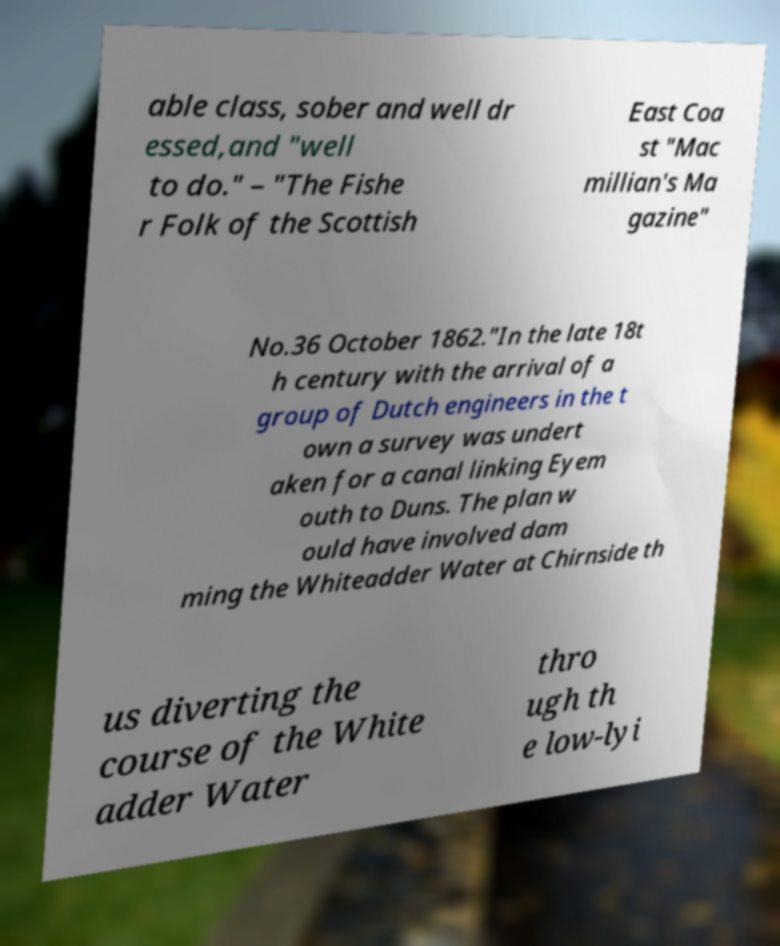Could you extract and type out the text from this image? able class, sober and well dr essed,and "well to do." – "The Fishe r Folk of the Scottish East Coa st "Mac millian's Ma gazine" No.36 October 1862."In the late 18t h century with the arrival of a group of Dutch engineers in the t own a survey was undert aken for a canal linking Eyem outh to Duns. The plan w ould have involved dam ming the Whiteadder Water at Chirnside th us diverting the course of the White adder Water thro ugh th e low-lyi 